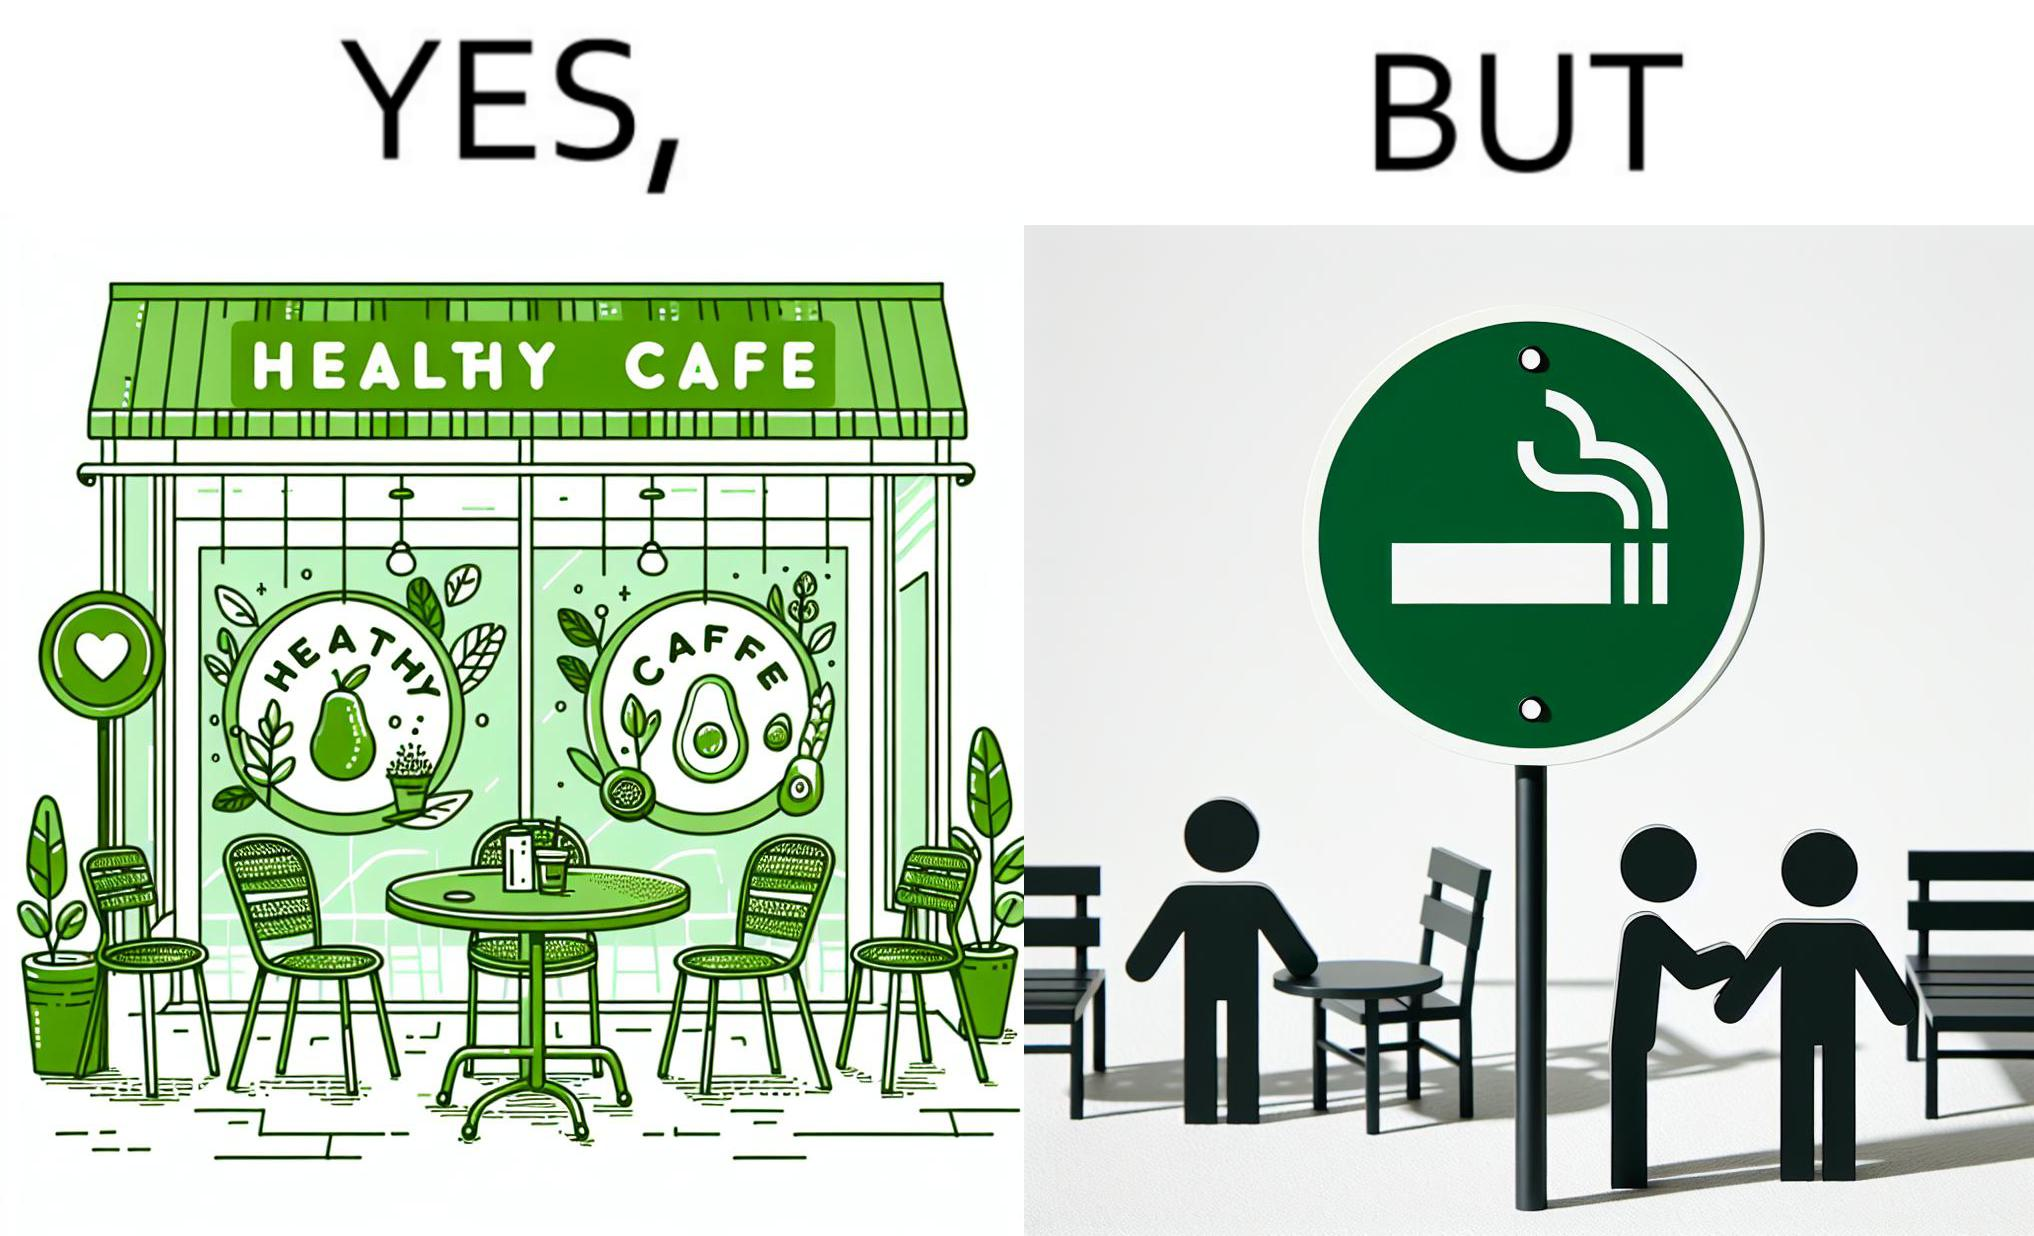Is there satirical content in this image? Yes, this image is satirical. 